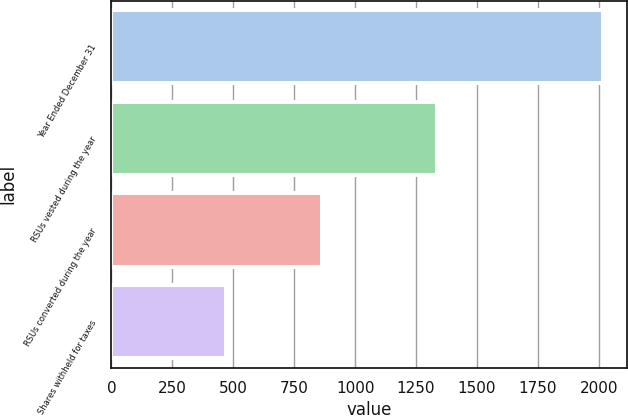Convert chart. <chart><loc_0><loc_0><loc_500><loc_500><bar_chart><fcel>Year Ended December 31<fcel>RSUs vested during the year<fcel>RSUs converted during the year<fcel>Shares withheld for taxes<nl><fcel>2017<fcel>1337<fcel>865<fcel>472<nl></chart> 